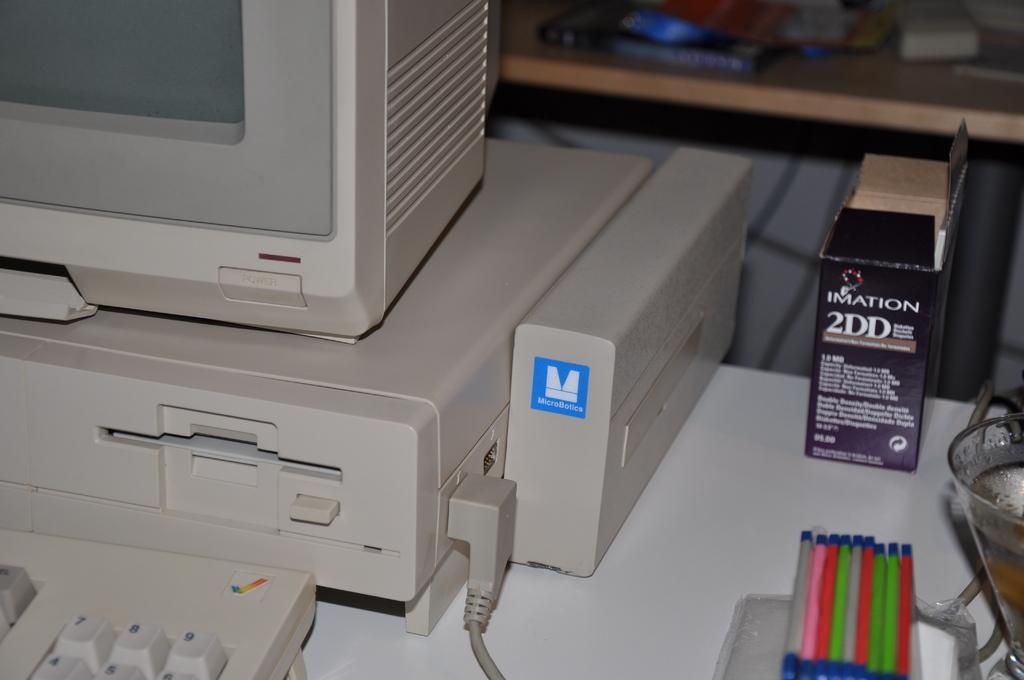Please provide a concise description of this image. Here there is monitor, keyboard, box is present. 